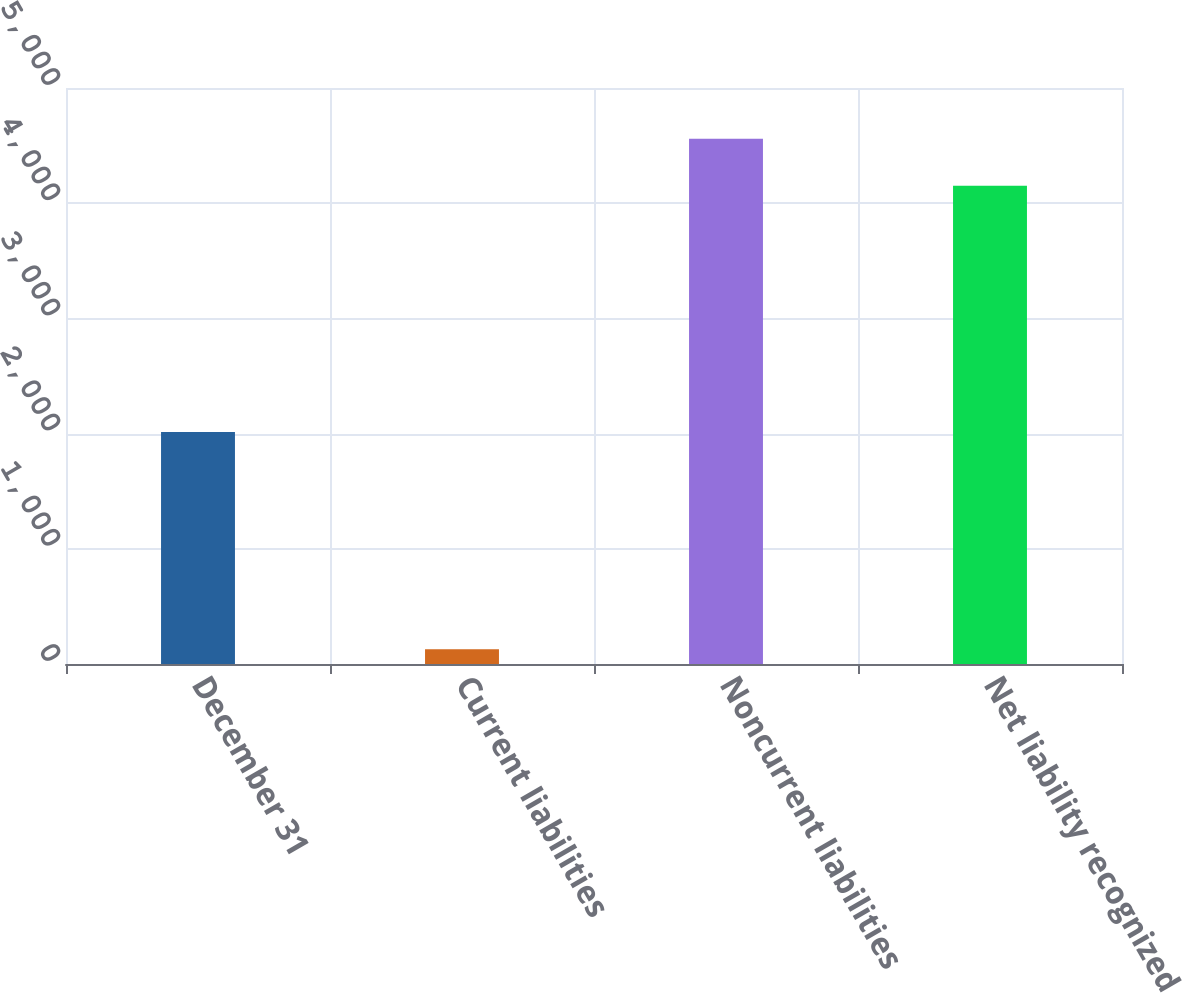<chart> <loc_0><loc_0><loc_500><loc_500><bar_chart><fcel>December 31<fcel>Current liabilities<fcel>Noncurrent liabilities<fcel>Net liability recognized<nl><fcel>2014<fcel>128<fcel>4559.2<fcel>4152<nl></chart> 